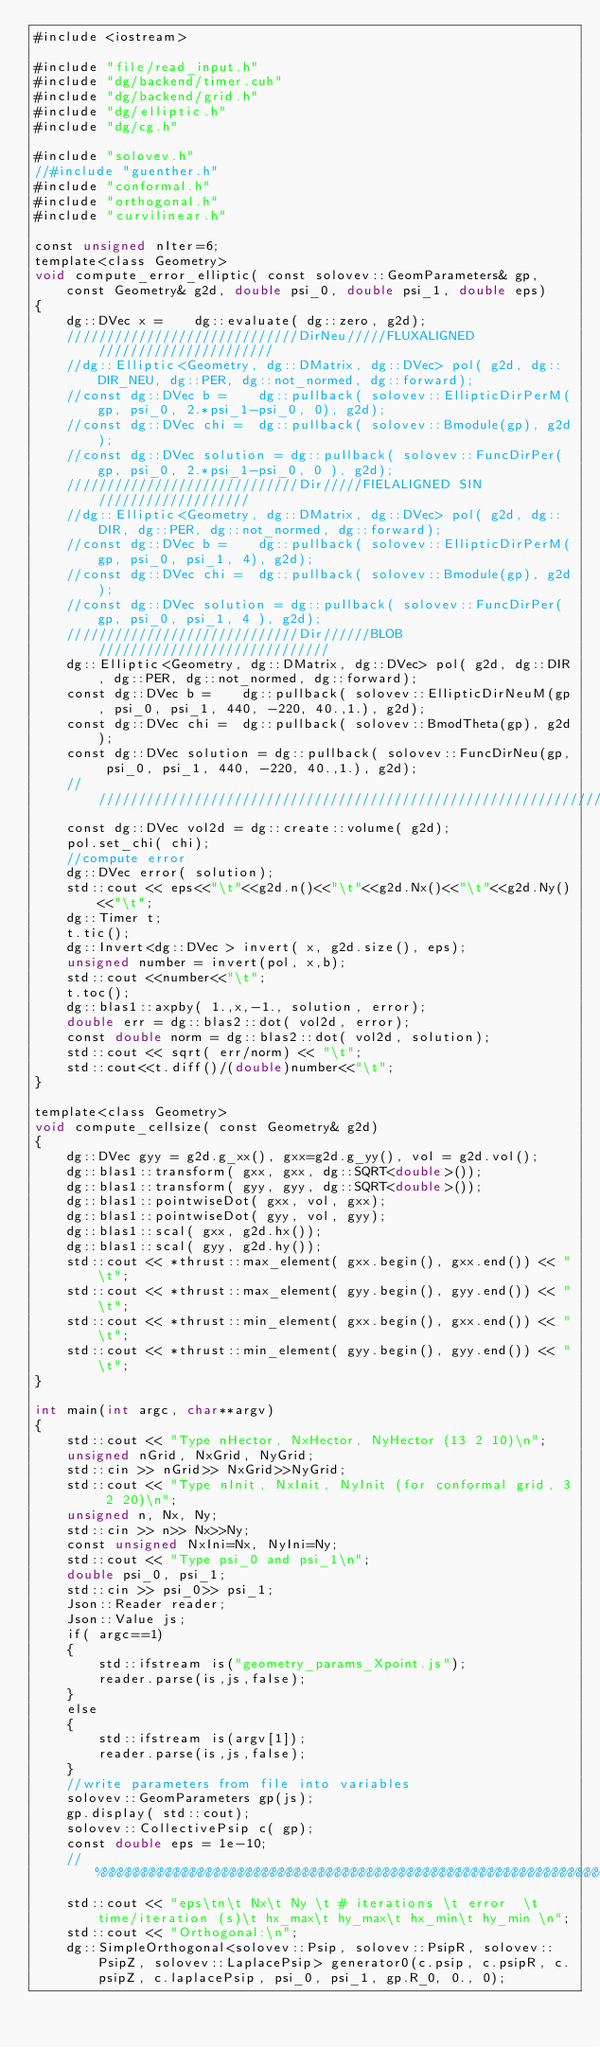<code> <loc_0><loc_0><loc_500><loc_500><_Cuda_>#include <iostream>

#include "file/read_input.h"
#include "dg/backend/timer.cuh"
#include "dg/backend/grid.h"
#include "dg/elliptic.h"
#include "dg/cg.h"

#include "solovev.h"
//#include "guenther.h"
#include "conformal.h"
#include "orthogonal.h"
#include "curvilinear.h"

const unsigned nIter=6;
template<class Geometry>
void compute_error_elliptic( const solovev::GeomParameters& gp, const Geometry& g2d, double psi_0, double psi_1, double eps)
{
    dg::DVec x =    dg::evaluate( dg::zero, g2d);
    /////////////////////////////DirNeu/////FLUXALIGNED//////////////////////
    //dg::Elliptic<Geometry, dg::DMatrix, dg::DVec> pol( g2d, dg::DIR_NEU, dg::PER, dg::not_normed, dg::forward);
    //const dg::DVec b =    dg::pullback( solovev::EllipticDirPerM(gp, psi_0, 2.*psi_1-psi_0, 0), g2d);
    //const dg::DVec chi =  dg::pullback( solovev::Bmodule(gp), g2d);
    //const dg::DVec solution = dg::pullback( solovev::FuncDirPer(gp, psi_0, 2.*psi_1-psi_0, 0 ), g2d);
    /////////////////////////////Dir/////FIELALIGNED SIN///////////////////
    //dg::Elliptic<Geometry, dg::DMatrix, dg::DVec> pol( g2d, dg::DIR, dg::PER, dg::not_normed, dg::forward);
    //const dg::DVec b =    dg::pullback( solovev::EllipticDirPerM(gp, psi_0, psi_1, 4), g2d);
    //const dg::DVec chi =  dg::pullback( solovev::Bmodule(gp), g2d);
    //const dg::DVec solution = dg::pullback( solovev::FuncDirPer(gp, psi_0, psi_1, 4 ), g2d);
    /////////////////////////////Dir//////BLOB/////////////////////////////
    dg::Elliptic<Geometry, dg::DMatrix, dg::DVec> pol( g2d, dg::DIR, dg::PER, dg::not_normed, dg::forward);
    const dg::DVec b =    dg::pullback( solovev::EllipticDirNeuM(gp, psi_0, psi_1, 440, -220, 40.,1.), g2d);
    const dg::DVec chi =  dg::pullback( solovev::BmodTheta(gp), g2d);
    const dg::DVec solution = dg::pullback( solovev::FuncDirNeu(gp, psi_0, psi_1, 440, -220, 40.,1.), g2d);
    ///////////////////////////////////////////////////////////////////////
    const dg::DVec vol2d = dg::create::volume( g2d);
    pol.set_chi( chi);
    //compute error
    dg::DVec error( solution);
    std::cout << eps<<"\t"<<g2d.n()<<"\t"<<g2d.Nx()<<"\t"<<g2d.Ny()<<"\t";
    dg::Timer t;
    t.tic();
    dg::Invert<dg::DVec > invert( x, g2d.size(), eps);
    unsigned number = invert(pol, x,b);
    std::cout <<number<<"\t";
    t.toc();
    dg::blas1::axpby( 1.,x,-1., solution, error);
    double err = dg::blas2::dot( vol2d, error);
    const double norm = dg::blas2::dot( vol2d, solution);
    std::cout << sqrt( err/norm) << "\t";
    std::cout<<t.diff()/(double)number<<"\t";
}

template<class Geometry>
void compute_cellsize( const Geometry& g2d)
{
    dg::DVec gyy = g2d.g_xx(), gxx=g2d.g_yy(), vol = g2d.vol();
    dg::blas1::transform( gxx, gxx, dg::SQRT<double>());
    dg::blas1::transform( gyy, gyy, dg::SQRT<double>());
    dg::blas1::pointwiseDot( gxx, vol, gxx);
    dg::blas1::pointwiseDot( gyy, vol, gyy);
    dg::blas1::scal( gxx, g2d.hx());
    dg::blas1::scal( gyy, g2d.hy());
    std::cout << *thrust::max_element( gxx.begin(), gxx.end()) << "\t";
    std::cout << *thrust::max_element( gyy.begin(), gyy.end()) << "\t";
    std::cout << *thrust::min_element( gxx.begin(), gxx.end()) << "\t";
    std::cout << *thrust::min_element( gyy.begin(), gyy.end()) << "\t";
}

int main(int argc, char**argv)
{
    std::cout << "Type nHector, NxHector, NyHector (13 2 10)\n";
    unsigned nGrid, NxGrid, NyGrid;
    std::cin >> nGrid>> NxGrid>>NyGrid;   
    std::cout << "Type nInit, NxInit, NyInit (for conformal grid, 3 2 20)\n";
    unsigned n, Nx, Ny;
    std::cin >> n>> Nx>>Ny;   
    const unsigned NxIni=Nx, NyIni=Ny;
    std::cout << "Type psi_0 and psi_1\n";
    double psi_0, psi_1;
    std::cin >> psi_0>> psi_1;
    Json::Reader reader;
    Json::Value js;
    if( argc==1)
    {
        std::ifstream is("geometry_params_Xpoint.js");
        reader.parse(is,js,false);
    }
    else
    {
        std::ifstream is(argv[1]);
        reader.parse(is,js,false);
    }
    //write parameters from file into variables
    solovev::GeomParameters gp(js);
    gp.display( std::cout);
    solovev::CollectivePsip c( gp); 
    const double eps = 1e-10;
    //%%%%%%%%%%%%%%%%%%%%%%%%%%%%%%%%%%%%%%%%%%%%%%%%%%%%%%%%%%%%%%%%%%%%%%%
    std::cout << "eps\tn\t Nx\t Ny \t # iterations \t error  \t time/iteration (s)\t hx_max\t hy_max\t hx_min\t hy_min \n";
    std::cout << "Orthogonal:\n";
    dg::SimpleOrthogonal<solovev::Psip, solovev::PsipR, solovev::PsipZ, solovev::LaplacePsip> generator0(c.psip, c.psipR, c.psipZ, c.laplacePsip, psi_0, psi_1, gp.R_0, 0., 0);</code> 